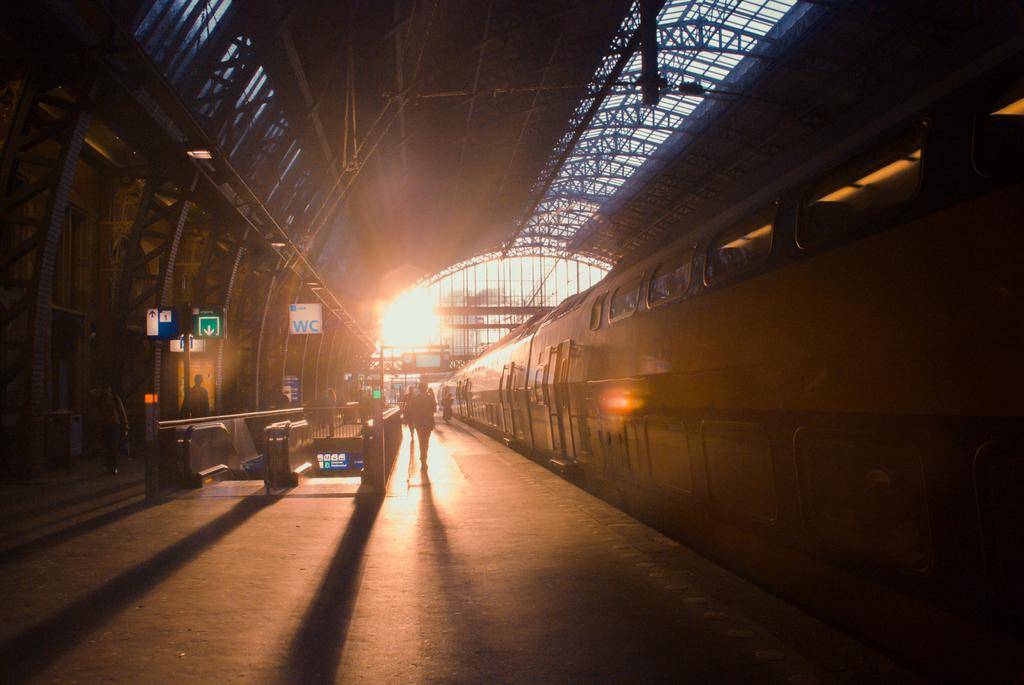<image>
Describe the image concisely. A train station tunnel with people walking through the tunnel next to a train with sign post of  a green down arrow and another with the letters WC. 